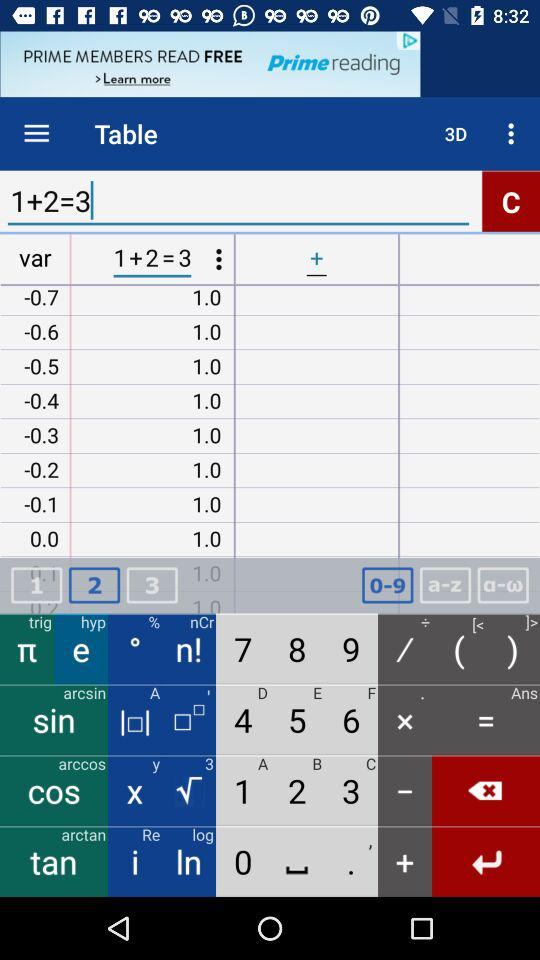What is the value of the variable after adding 1?
Answer the question using a single word or phrase. 4 